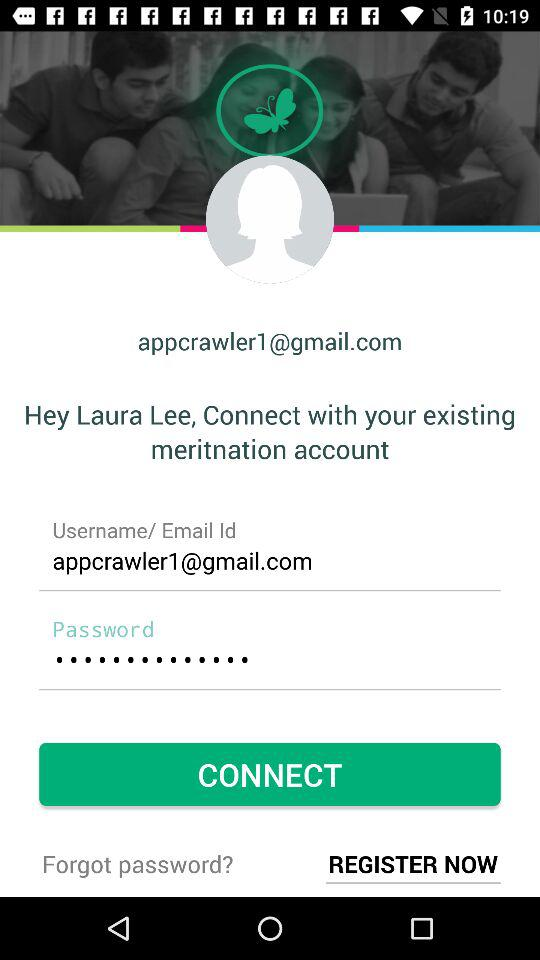What is the user name? The user name is Laura Lee. 